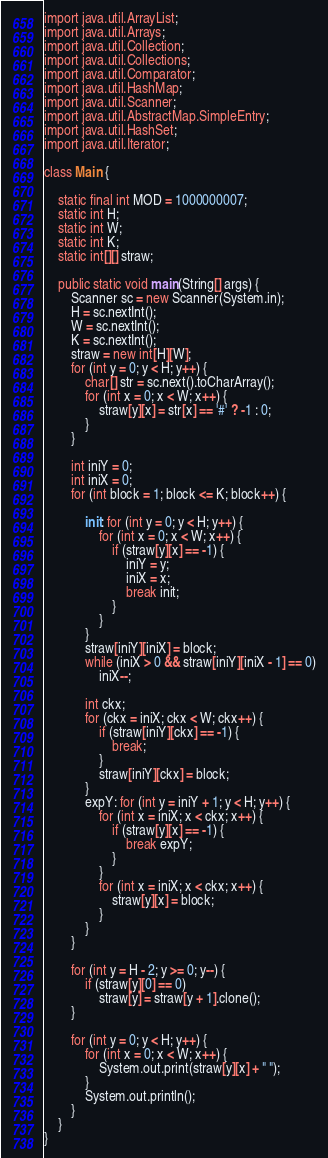<code> <loc_0><loc_0><loc_500><loc_500><_Java_>
import java.util.ArrayList;
import java.util.Arrays;
import java.util.Collection;
import java.util.Collections;
import java.util.Comparator;
import java.util.HashMap;
import java.util.Scanner;
import java.util.AbstractMap.SimpleEntry;
import java.util.HashSet;
import java.util.Iterator;

class Main {

    static final int MOD = 1000000007;
    static int H;
    static int W;
    static int K;
    static int[][] straw;

    public static void main(String[] args) {
        Scanner sc = new Scanner(System.in);
        H = sc.nextInt();
        W = sc.nextInt();
        K = sc.nextInt();
        straw = new int[H][W];
        for (int y = 0; y < H; y++) {
            char[] str = sc.next().toCharArray();
            for (int x = 0; x < W; x++) {
                straw[y][x] = str[x] == '#' ? -1 : 0;
            }
        }

        int iniY = 0;
        int iniX = 0;
        for (int block = 1; block <= K; block++) {

            init: for (int y = 0; y < H; y++) {
                for (int x = 0; x < W; x++) {
                    if (straw[y][x] == -1) {
                        iniY = y;
                        iniX = x;
                        break init;
                    }
                }
            }
            straw[iniY][iniX] = block;
            while (iniX > 0 && straw[iniY][iniX - 1] == 0)
                iniX--;

            int ckx;
            for (ckx = iniX; ckx < W; ckx++) {
                if (straw[iniY][ckx] == -1) {
                    break;
                }
                straw[iniY][ckx] = block;
            }
            expY: for (int y = iniY + 1; y < H; y++) {
                for (int x = iniX; x < ckx; x++) {
                    if (straw[y][x] == -1) {
                        break expY;
                    }
                }
                for (int x = iniX; x < ckx; x++) {
                    straw[y][x] = block;
                }
            }
        }

        for (int y = H - 2; y >= 0; y--) {
            if (straw[y][0] == 0)
                straw[y] = straw[y + 1].clone();
        }

        for (int y = 0; y < H; y++) {
            for (int x = 0; x < W; x++) {
                System.out.print(straw[y][x] + " ");
            }
            System.out.println();
        }
    }
}</code> 